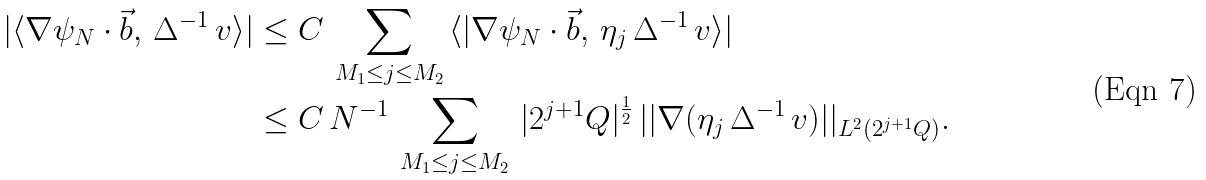Convert formula to latex. <formula><loc_0><loc_0><loc_500><loc_500>| \langle \nabla \psi _ { N } \cdot \vec { b } , \, \Delta ^ { - 1 } \, v \rangle | & \leq C \, \sum _ { M _ { 1 } \leq j \leq M _ { 2 } } \, \langle | \nabla \psi _ { N } \cdot \vec { b } , \, \eta _ { j } \, \Delta ^ { - 1 } \, v \rangle | \\ & \leq C \, N ^ { - 1 } \, \sum _ { M _ { 1 } \leq j \leq M _ { 2 } } \, | 2 ^ { j + 1 } Q | ^ { \frac { 1 } { 2 } } \, | | \nabla ( \eta _ { j } \, \Delta ^ { - 1 } \, v ) | | _ { L ^ { 2 } ( 2 ^ { j + 1 } Q ) } .</formula> 